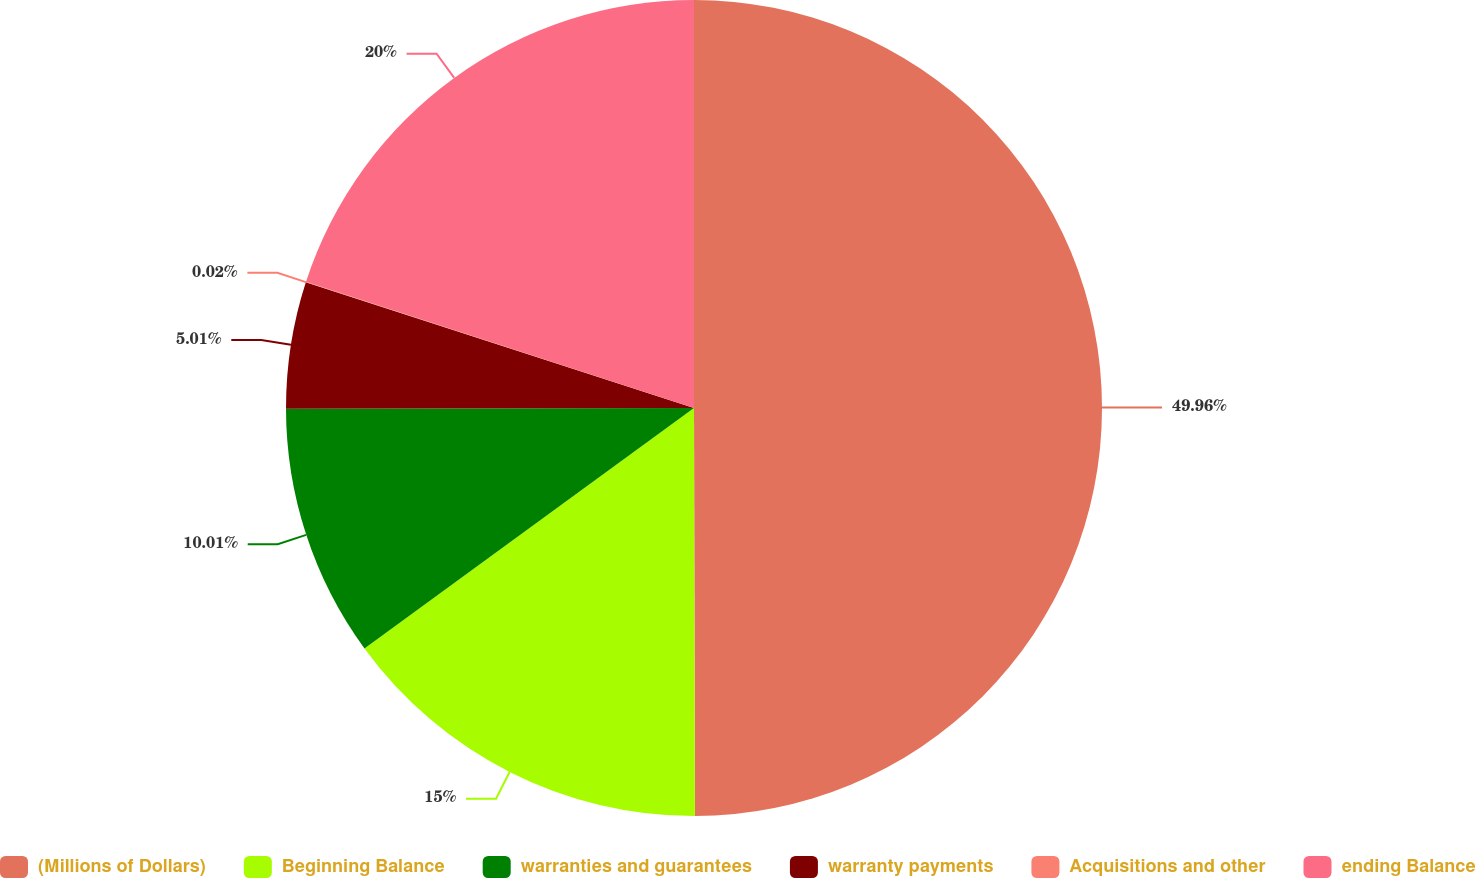Convert chart to OTSL. <chart><loc_0><loc_0><loc_500><loc_500><pie_chart><fcel>(Millions of Dollars)<fcel>Beginning Balance<fcel>warranties and guarantees<fcel>warranty payments<fcel>Acquisitions and other<fcel>ending Balance<nl><fcel>49.97%<fcel>15.0%<fcel>10.01%<fcel>5.01%<fcel>0.02%<fcel>20.0%<nl></chart> 